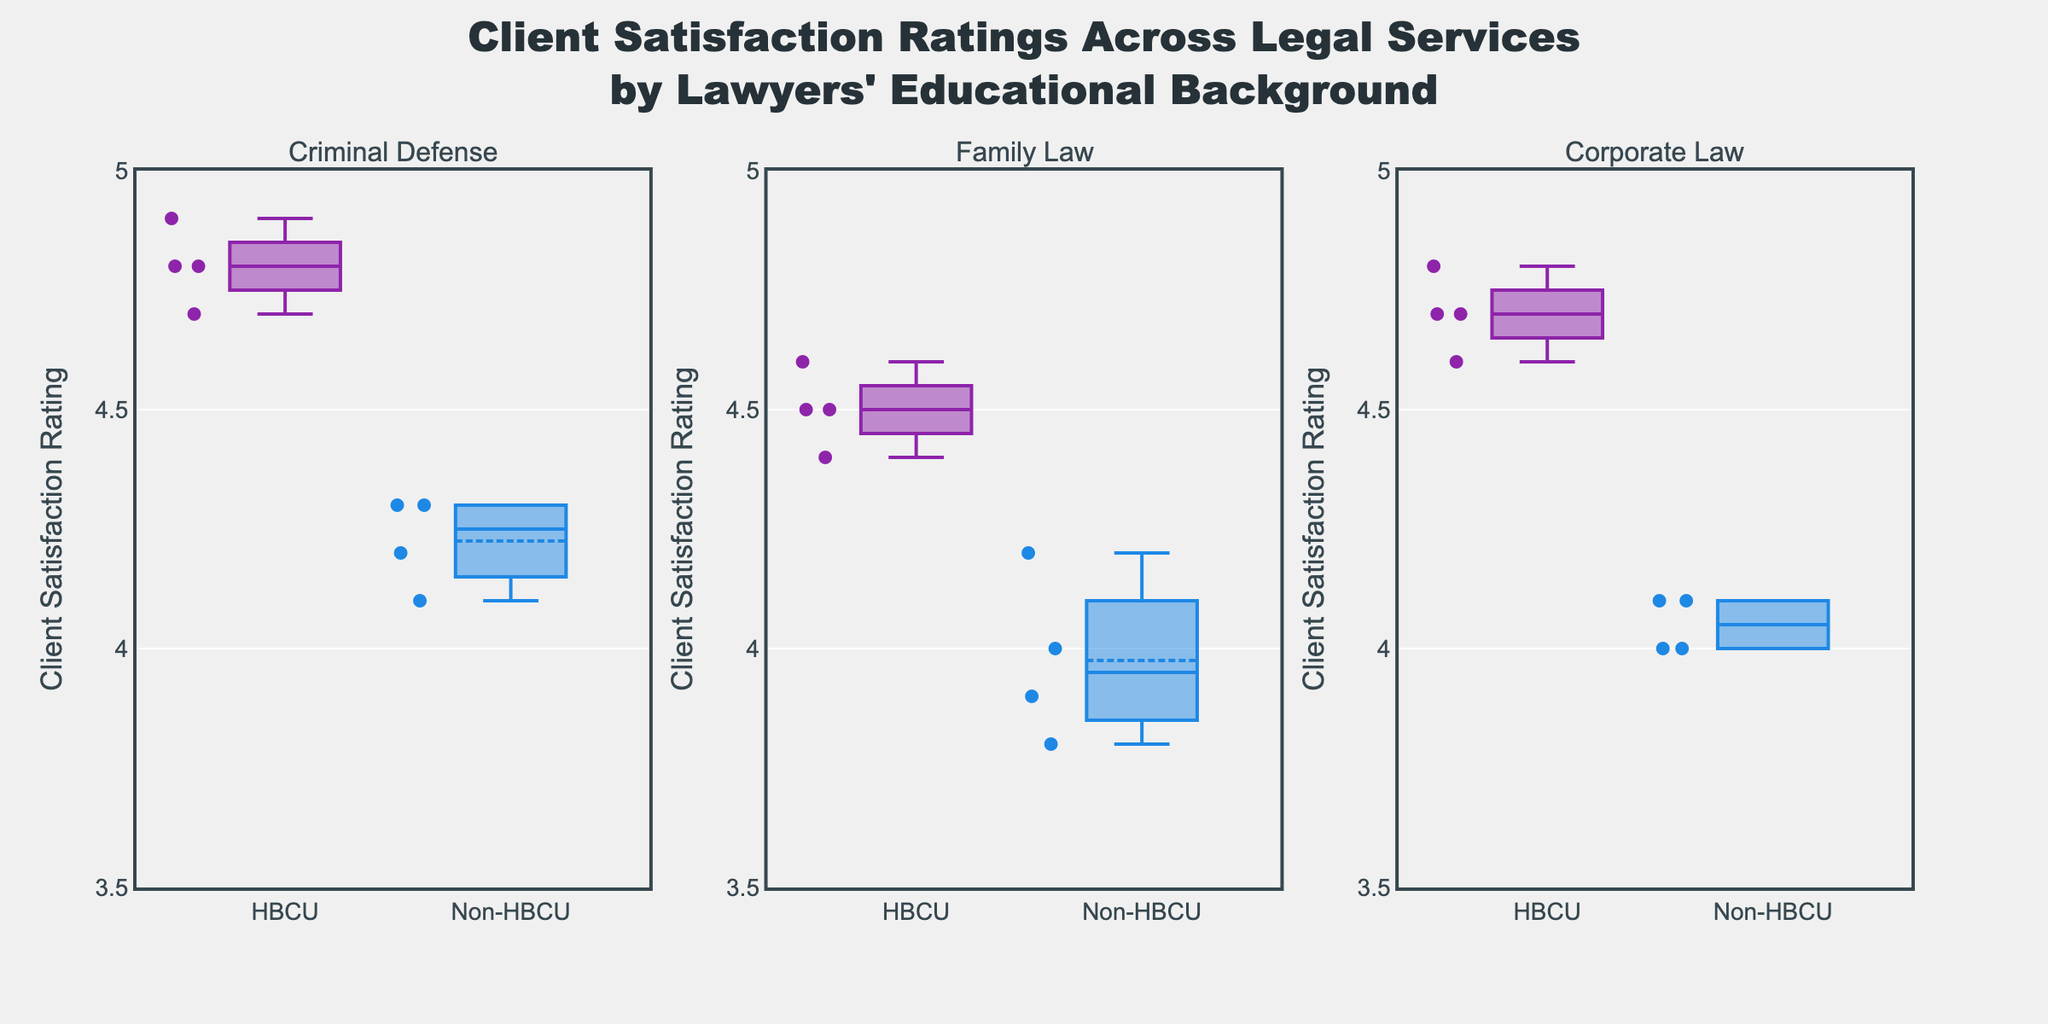What is the title of the figure? The title is typically placed at the top of the figure and is usually larger and bolder than the rest of the text. It summarizes the content of the figure.
Answer: Client Satisfaction Ratings Across Legal Services by Lawyers' Educational Background Which educational background has a higher median client satisfaction rating in Criminal Defense? Look at the median lines (center lines inside the boxes) for HBCU and Non-HBCU in the Criminal Defense subplot. The higher median line indicates the higher median rating.
Answer: HBCU What is the range of client satisfaction ratings for Non-HBCU lawyers in Family Law? The range is found by looking at the bottom and top of the whiskers of the box plot for Non-HBCU in the Family Law subplot. These whiskers represent the minimum and maximum values.
Answer: 3.8 to 4.2 Is the median client satisfaction rating for HBCU lawyers in Corporate Law above 4.5? Check the position of the median line (center line inside the box) for HBCU in the Corporate Law subplot to see if it is above the 4.5 mark.
Answer: Yes Do Non-HBCU lawyers receive higher client satisfaction ratings in Family Law or Corporate Law? Compare the median lines (center lines inside the boxes) for Non-HBCU in Family Law and Corporate Law subplots. The subplot with the higher median line indicates higher ratings.
Answer: Corporate Law How many educational backgrounds are compared in the figure? Count the distinct box plots or names in the x-axis labels across all subplots.
Answer: 2 In which legal service do HBCU lawyers have the highest variability in client satisfaction ratings? Look at the spread (interquartile range) of the HBCU box plots across different subplots. The one with the widest box has the highest variability.
Answer: Family Law Which legal service shows the smallest difference in median client satisfaction ratings between HBCU and Non-HBCU lawyers? Compare the distance between the median lines (center lines inside the boxes) for HBCU and Non-HBCU in each subplot. The subplot with the smallest distance shows the smallest difference.
Answer: Corporate Law What can be inferred about the overall satisfaction trends between HBCU and Non-HBCU lawyers across the three legal services? Look at the median positions and general spread of the box plots for HBCU and Non-HBCU across all subplots. Summarize the general trends.
Answer: HBCU lawyers generally have higher median satisfaction ratings across all services 